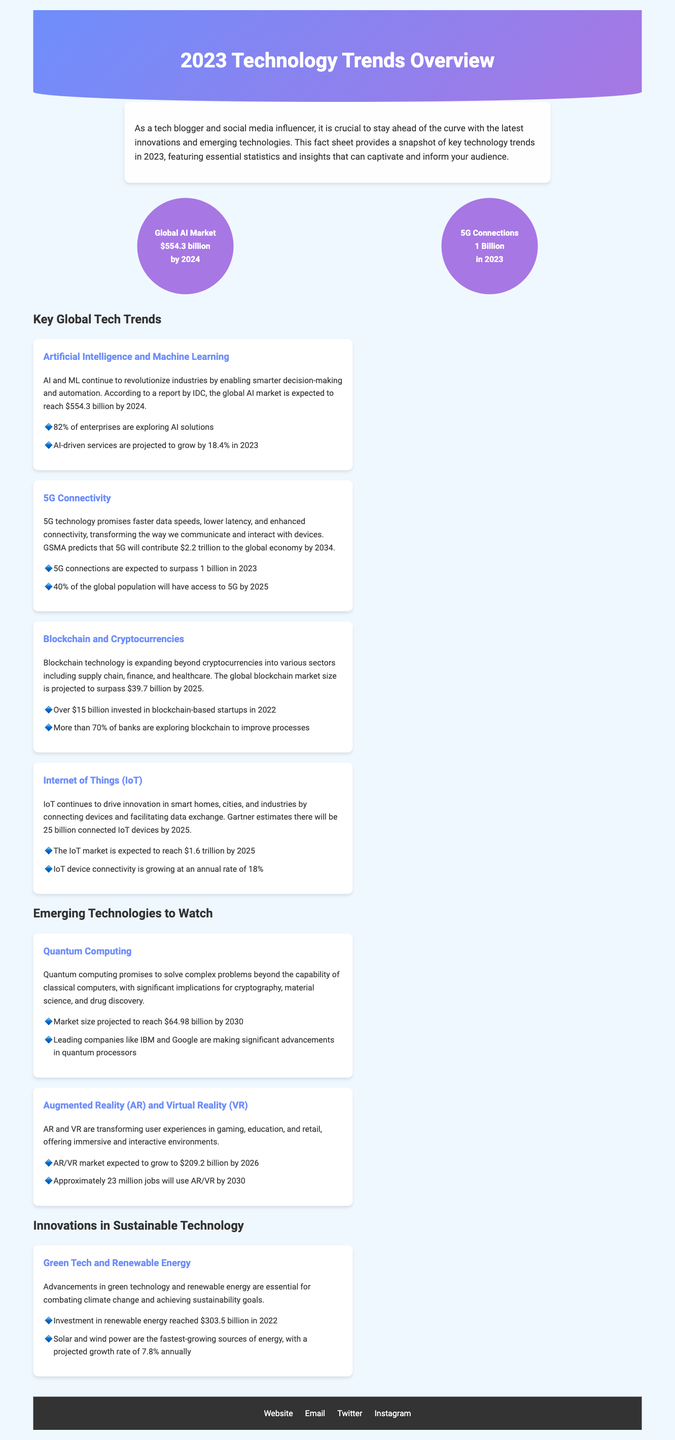what is the projected global AI market size by 2024? The document states the global AI market is expected to reach $554.3 billion by 2024.
Answer: $554.3 billion how many 5G connections are expected in 2023? According to the document, 5G connections are expected to surpass 1 billion in 2023.
Answer: 1 billion what is the projected market size for blockchain by 2025? The document indicates the global blockchain market size is projected to surpass $39.7 billion by 2025.
Answer: $39.7 billion what percentage of enterprises are exploring AI solutions? The document mentions that 82% of enterprises are exploring AI solutions.
Answer: 82% which technology is expected to have 25 billion connected devices by 2025? The document notes that the Internet of Things (IoT) is expected to have 25 billion connected devices by 2025.
Answer: Internet of Things (IoT) what is the expected growth rate of solar and wind power? The document states that solar and wind power have a projected growth rate of 7.8% annually.
Answer: 7.8% which two companies are making advancements in quantum processors? The document lists IBM and Google as leading companies making advancements in quantum processors.
Answer: IBM and Google what is the expected AR/VR market size by 2026? According to the document, the AR/VR market is expected to grow to $209.2 billion by 2026.
Answer: $209.2 billion what is the total investment in renewable energy reached in 2022? The document states that investment in renewable energy reached $303.5 billion in 2022.
Answer: $303.5 billion 